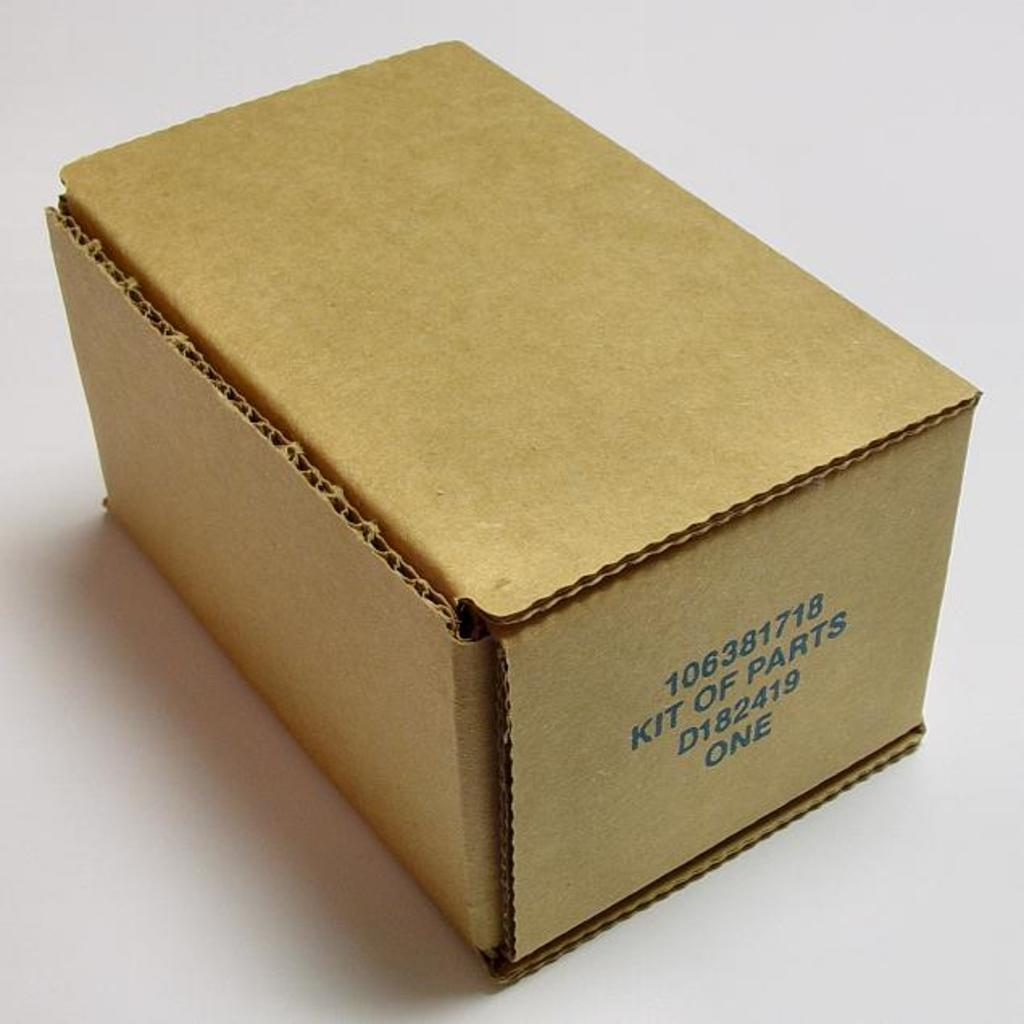<image>
Create a compact narrative representing the image presented. A brown cardboard box with the number 106381718 printed in blue. 